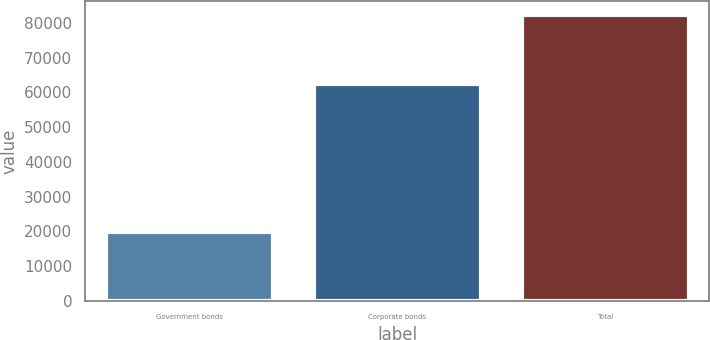Convert chart. <chart><loc_0><loc_0><loc_500><loc_500><bar_chart><fcel>Government bonds<fcel>Corporate bonds<fcel>Total<nl><fcel>19884<fcel>62360<fcel>82244<nl></chart> 